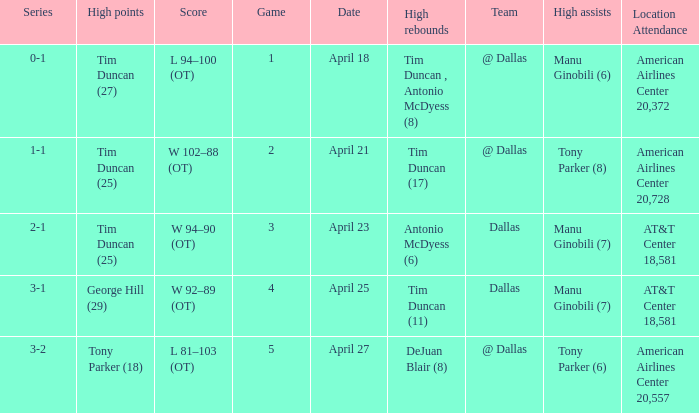When george hill (29) has the highest amount of points what is the date? April 25. 